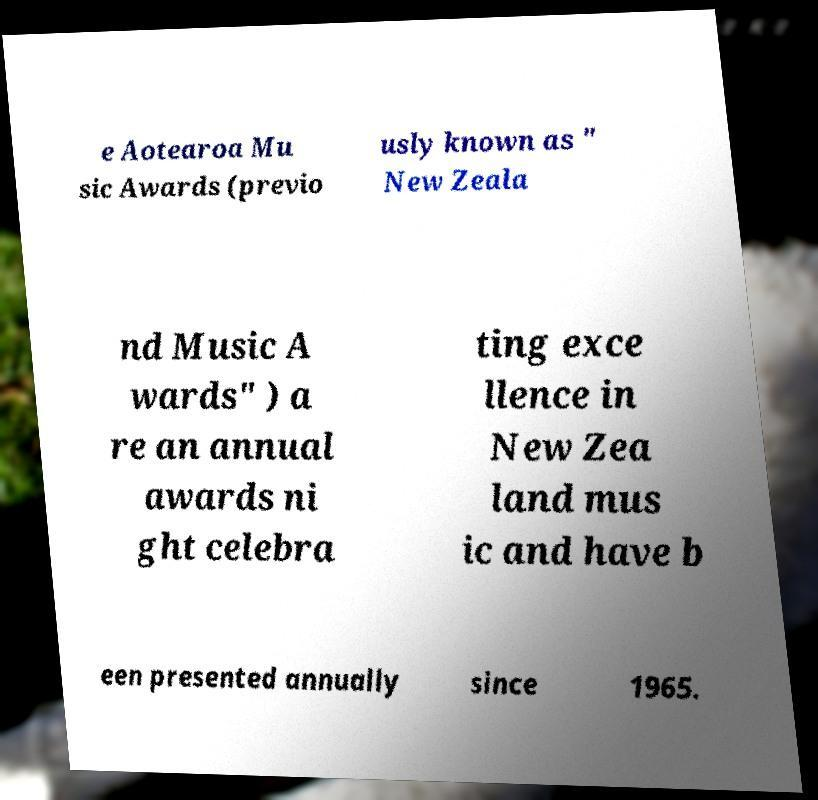For documentation purposes, I need the text within this image transcribed. Could you provide that? e Aotearoa Mu sic Awards (previo usly known as " New Zeala nd Music A wards" ) a re an annual awards ni ght celebra ting exce llence in New Zea land mus ic and have b een presented annually since 1965. 